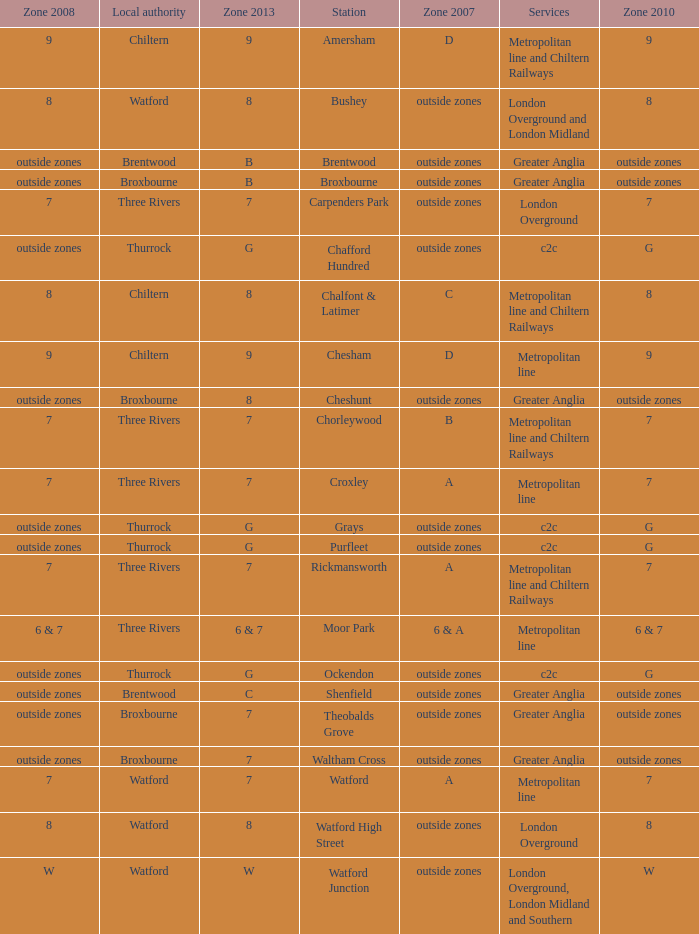Which Zone 2008 has Services of greater anglia, and a Station of cheshunt? Outside zones. 